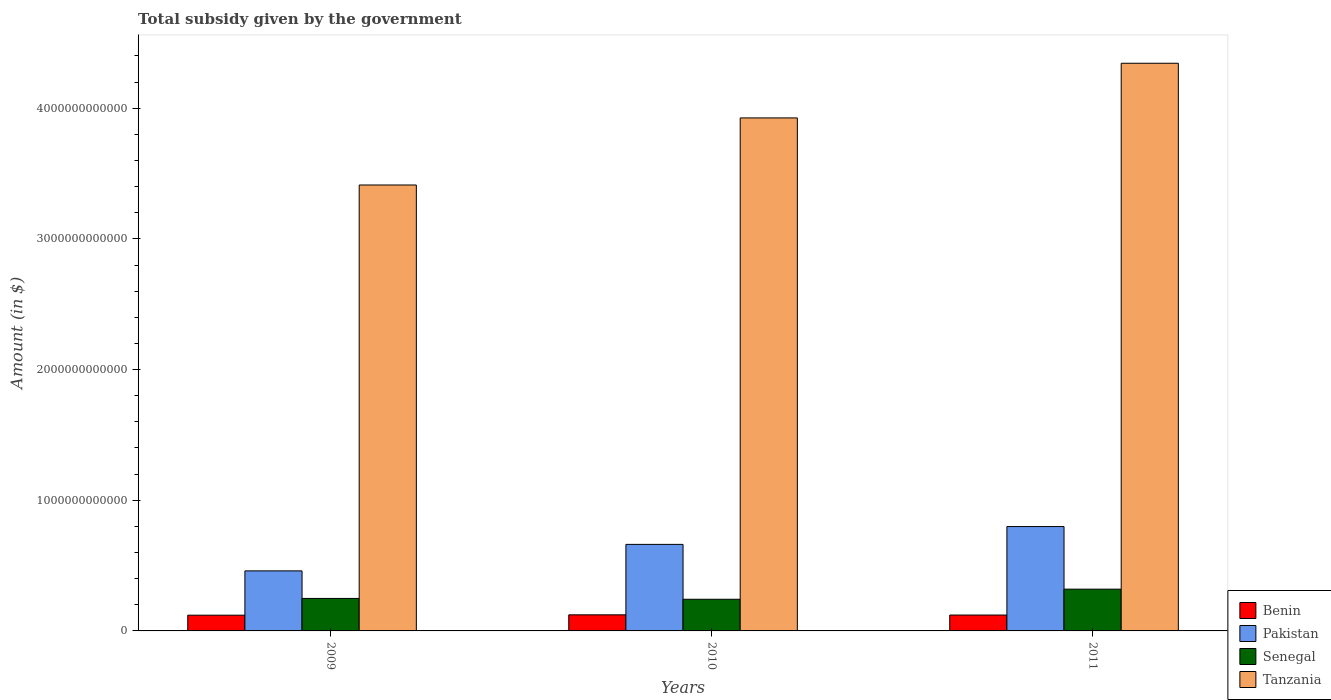How many groups of bars are there?
Your answer should be very brief. 3. Are the number of bars per tick equal to the number of legend labels?
Make the answer very short. Yes. How many bars are there on the 1st tick from the right?
Offer a very short reply. 4. What is the total revenue collected by the government in Pakistan in 2011?
Keep it short and to the point. 7.99e+11. Across all years, what is the maximum total revenue collected by the government in Pakistan?
Give a very brief answer. 7.99e+11. Across all years, what is the minimum total revenue collected by the government in Pakistan?
Your answer should be compact. 4.59e+11. In which year was the total revenue collected by the government in Tanzania maximum?
Provide a succinct answer. 2011. What is the total total revenue collected by the government in Benin in the graph?
Give a very brief answer. 3.65e+11. What is the difference between the total revenue collected by the government in Benin in 2009 and that in 2011?
Your answer should be very brief. -1.11e+09. What is the difference between the total revenue collected by the government in Pakistan in 2010 and the total revenue collected by the government in Benin in 2009?
Ensure brevity in your answer.  5.42e+11. What is the average total revenue collected by the government in Tanzania per year?
Your response must be concise. 3.89e+12. In the year 2010, what is the difference between the total revenue collected by the government in Senegal and total revenue collected by the government in Tanzania?
Make the answer very short. -3.68e+12. In how many years, is the total revenue collected by the government in Pakistan greater than 2000000000000 $?
Offer a terse response. 0. What is the ratio of the total revenue collected by the government in Benin in 2009 to that in 2010?
Your answer should be very brief. 0.98. Is the total revenue collected by the government in Tanzania in 2010 less than that in 2011?
Provide a succinct answer. Yes. Is the difference between the total revenue collected by the government in Senegal in 2010 and 2011 greater than the difference between the total revenue collected by the government in Tanzania in 2010 and 2011?
Give a very brief answer. Yes. What is the difference between the highest and the second highest total revenue collected by the government in Benin?
Give a very brief answer. 1.58e+09. What is the difference between the highest and the lowest total revenue collected by the government in Pakistan?
Your answer should be compact. 3.39e+11. Is the sum of the total revenue collected by the government in Tanzania in 2009 and 2011 greater than the maximum total revenue collected by the government in Pakistan across all years?
Your response must be concise. Yes. What does the 2nd bar from the left in 2009 represents?
Offer a terse response. Pakistan. What does the 1st bar from the right in 2010 represents?
Offer a terse response. Tanzania. How many bars are there?
Ensure brevity in your answer.  12. Are all the bars in the graph horizontal?
Offer a very short reply. No. What is the difference between two consecutive major ticks on the Y-axis?
Give a very brief answer. 1.00e+12. How many legend labels are there?
Your response must be concise. 4. How are the legend labels stacked?
Make the answer very short. Vertical. What is the title of the graph?
Give a very brief answer. Total subsidy given by the government. What is the label or title of the Y-axis?
Provide a short and direct response. Amount (in $). What is the Amount (in $) of Benin in 2009?
Offer a very short reply. 1.20e+11. What is the Amount (in $) in Pakistan in 2009?
Keep it short and to the point. 4.59e+11. What is the Amount (in $) of Senegal in 2009?
Your answer should be compact. 2.49e+11. What is the Amount (in $) in Tanzania in 2009?
Provide a short and direct response. 3.41e+12. What is the Amount (in $) in Benin in 2010?
Keep it short and to the point. 1.23e+11. What is the Amount (in $) in Pakistan in 2010?
Provide a succinct answer. 6.62e+11. What is the Amount (in $) of Senegal in 2010?
Ensure brevity in your answer.  2.42e+11. What is the Amount (in $) of Tanzania in 2010?
Provide a succinct answer. 3.93e+12. What is the Amount (in $) of Benin in 2011?
Your answer should be compact. 1.22e+11. What is the Amount (in $) of Pakistan in 2011?
Offer a very short reply. 7.99e+11. What is the Amount (in $) in Senegal in 2011?
Provide a short and direct response. 3.20e+11. What is the Amount (in $) of Tanzania in 2011?
Give a very brief answer. 4.34e+12. Across all years, what is the maximum Amount (in $) in Benin?
Keep it short and to the point. 1.23e+11. Across all years, what is the maximum Amount (in $) of Pakistan?
Your answer should be very brief. 7.99e+11. Across all years, what is the maximum Amount (in $) in Senegal?
Your answer should be very brief. 3.20e+11. Across all years, what is the maximum Amount (in $) of Tanzania?
Your response must be concise. 4.34e+12. Across all years, what is the minimum Amount (in $) of Benin?
Give a very brief answer. 1.20e+11. Across all years, what is the minimum Amount (in $) of Pakistan?
Keep it short and to the point. 4.59e+11. Across all years, what is the minimum Amount (in $) of Senegal?
Your answer should be very brief. 2.42e+11. Across all years, what is the minimum Amount (in $) in Tanzania?
Ensure brevity in your answer.  3.41e+12. What is the total Amount (in $) in Benin in the graph?
Offer a terse response. 3.65e+11. What is the total Amount (in $) in Pakistan in the graph?
Your answer should be compact. 1.92e+12. What is the total Amount (in $) in Senegal in the graph?
Ensure brevity in your answer.  8.10e+11. What is the total Amount (in $) in Tanzania in the graph?
Offer a terse response. 1.17e+13. What is the difference between the Amount (in $) in Benin in 2009 and that in 2010?
Your response must be concise. -2.69e+09. What is the difference between the Amount (in $) in Pakistan in 2009 and that in 2010?
Provide a succinct answer. -2.03e+11. What is the difference between the Amount (in $) in Senegal in 2009 and that in 2010?
Offer a very short reply. 6.30e+09. What is the difference between the Amount (in $) of Tanzania in 2009 and that in 2010?
Ensure brevity in your answer.  -5.13e+11. What is the difference between the Amount (in $) of Benin in 2009 and that in 2011?
Keep it short and to the point. -1.11e+09. What is the difference between the Amount (in $) in Pakistan in 2009 and that in 2011?
Your response must be concise. -3.39e+11. What is the difference between the Amount (in $) of Senegal in 2009 and that in 2011?
Your response must be concise. -7.10e+1. What is the difference between the Amount (in $) in Tanzania in 2009 and that in 2011?
Keep it short and to the point. -9.32e+11. What is the difference between the Amount (in $) of Benin in 2010 and that in 2011?
Provide a succinct answer. 1.58e+09. What is the difference between the Amount (in $) of Pakistan in 2010 and that in 2011?
Offer a very short reply. -1.36e+11. What is the difference between the Amount (in $) in Senegal in 2010 and that in 2011?
Offer a terse response. -7.73e+1. What is the difference between the Amount (in $) in Tanzania in 2010 and that in 2011?
Make the answer very short. -4.18e+11. What is the difference between the Amount (in $) of Benin in 2009 and the Amount (in $) of Pakistan in 2010?
Make the answer very short. -5.42e+11. What is the difference between the Amount (in $) of Benin in 2009 and the Amount (in $) of Senegal in 2010?
Make the answer very short. -1.22e+11. What is the difference between the Amount (in $) in Benin in 2009 and the Amount (in $) in Tanzania in 2010?
Keep it short and to the point. -3.81e+12. What is the difference between the Amount (in $) of Pakistan in 2009 and the Amount (in $) of Senegal in 2010?
Offer a terse response. 2.17e+11. What is the difference between the Amount (in $) in Pakistan in 2009 and the Amount (in $) in Tanzania in 2010?
Give a very brief answer. -3.47e+12. What is the difference between the Amount (in $) of Senegal in 2009 and the Amount (in $) of Tanzania in 2010?
Ensure brevity in your answer.  -3.68e+12. What is the difference between the Amount (in $) of Benin in 2009 and the Amount (in $) of Pakistan in 2011?
Offer a terse response. -6.78e+11. What is the difference between the Amount (in $) of Benin in 2009 and the Amount (in $) of Senegal in 2011?
Provide a short and direct response. -1.99e+11. What is the difference between the Amount (in $) of Benin in 2009 and the Amount (in $) of Tanzania in 2011?
Provide a short and direct response. -4.22e+12. What is the difference between the Amount (in $) of Pakistan in 2009 and the Amount (in $) of Senegal in 2011?
Provide a short and direct response. 1.40e+11. What is the difference between the Amount (in $) in Pakistan in 2009 and the Amount (in $) in Tanzania in 2011?
Your answer should be compact. -3.88e+12. What is the difference between the Amount (in $) in Senegal in 2009 and the Amount (in $) in Tanzania in 2011?
Offer a terse response. -4.10e+12. What is the difference between the Amount (in $) in Benin in 2010 and the Amount (in $) in Pakistan in 2011?
Offer a terse response. -6.76e+11. What is the difference between the Amount (in $) in Benin in 2010 and the Amount (in $) in Senegal in 2011?
Provide a succinct answer. -1.97e+11. What is the difference between the Amount (in $) in Benin in 2010 and the Amount (in $) in Tanzania in 2011?
Provide a succinct answer. -4.22e+12. What is the difference between the Amount (in $) in Pakistan in 2010 and the Amount (in $) in Senegal in 2011?
Offer a terse response. 3.43e+11. What is the difference between the Amount (in $) of Pakistan in 2010 and the Amount (in $) of Tanzania in 2011?
Offer a very short reply. -3.68e+12. What is the difference between the Amount (in $) in Senegal in 2010 and the Amount (in $) in Tanzania in 2011?
Your response must be concise. -4.10e+12. What is the average Amount (in $) in Benin per year?
Offer a terse response. 1.22e+11. What is the average Amount (in $) of Pakistan per year?
Give a very brief answer. 6.40e+11. What is the average Amount (in $) of Senegal per year?
Provide a short and direct response. 2.70e+11. What is the average Amount (in $) in Tanzania per year?
Make the answer very short. 3.89e+12. In the year 2009, what is the difference between the Amount (in $) of Benin and Amount (in $) of Pakistan?
Offer a very short reply. -3.39e+11. In the year 2009, what is the difference between the Amount (in $) in Benin and Amount (in $) in Senegal?
Give a very brief answer. -1.28e+11. In the year 2009, what is the difference between the Amount (in $) in Benin and Amount (in $) in Tanzania?
Make the answer very short. -3.29e+12. In the year 2009, what is the difference between the Amount (in $) in Pakistan and Amount (in $) in Senegal?
Your answer should be compact. 2.11e+11. In the year 2009, what is the difference between the Amount (in $) of Pakistan and Amount (in $) of Tanzania?
Provide a short and direct response. -2.95e+12. In the year 2009, what is the difference between the Amount (in $) of Senegal and Amount (in $) of Tanzania?
Keep it short and to the point. -3.16e+12. In the year 2010, what is the difference between the Amount (in $) of Benin and Amount (in $) of Pakistan?
Your response must be concise. -5.39e+11. In the year 2010, what is the difference between the Amount (in $) of Benin and Amount (in $) of Senegal?
Your answer should be very brief. -1.19e+11. In the year 2010, what is the difference between the Amount (in $) of Benin and Amount (in $) of Tanzania?
Your answer should be compact. -3.80e+12. In the year 2010, what is the difference between the Amount (in $) of Pakistan and Amount (in $) of Senegal?
Your answer should be compact. 4.20e+11. In the year 2010, what is the difference between the Amount (in $) in Pakistan and Amount (in $) in Tanzania?
Provide a succinct answer. -3.26e+12. In the year 2010, what is the difference between the Amount (in $) in Senegal and Amount (in $) in Tanzania?
Provide a succinct answer. -3.68e+12. In the year 2011, what is the difference between the Amount (in $) in Benin and Amount (in $) in Pakistan?
Provide a succinct answer. -6.77e+11. In the year 2011, what is the difference between the Amount (in $) in Benin and Amount (in $) in Senegal?
Offer a very short reply. -1.98e+11. In the year 2011, what is the difference between the Amount (in $) of Benin and Amount (in $) of Tanzania?
Ensure brevity in your answer.  -4.22e+12. In the year 2011, what is the difference between the Amount (in $) of Pakistan and Amount (in $) of Senegal?
Make the answer very short. 4.79e+11. In the year 2011, what is the difference between the Amount (in $) of Pakistan and Amount (in $) of Tanzania?
Offer a very short reply. -3.55e+12. In the year 2011, what is the difference between the Amount (in $) of Senegal and Amount (in $) of Tanzania?
Provide a short and direct response. -4.02e+12. What is the ratio of the Amount (in $) of Benin in 2009 to that in 2010?
Your response must be concise. 0.98. What is the ratio of the Amount (in $) in Pakistan in 2009 to that in 2010?
Your response must be concise. 0.69. What is the ratio of the Amount (in $) in Senegal in 2009 to that in 2010?
Make the answer very short. 1.03. What is the ratio of the Amount (in $) in Tanzania in 2009 to that in 2010?
Your answer should be very brief. 0.87. What is the ratio of the Amount (in $) of Benin in 2009 to that in 2011?
Give a very brief answer. 0.99. What is the ratio of the Amount (in $) of Pakistan in 2009 to that in 2011?
Offer a terse response. 0.58. What is the ratio of the Amount (in $) in Senegal in 2009 to that in 2011?
Keep it short and to the point. 0.78. What is the ratio of the Amount (in $) in Tanzania in 2009 to that in 2011?
Your answer should be compact. 0.79. What is the ratio of the Amount (in $) of Pakistan in 2010 to that in 2011?
Ensure brevity in your answer.  0.83. What is the ratio of the Amount (in $) in Senegal in 2010 to that in 2011?
Make the answer very short. 0.76. What is the ratio of the Amount (in $) in Tanzania in 2010 to that in 2011?
Your answer should be very brief. 0.9. What is the difference between the highest and the second highest Amount (in $) of Benin?
Keep it short and to the point. 1.58e+09. What is the difference between the highest and the second highest Amount (in $) of Pakistan?
Make the answer very short. 1.36e+11. What is the difference between the highest and the second highest Amount (in $) of Senegal?
Your answer should be compact. 7.10e+1. What is the difference between the highest and the second highest Amount (in $) in Tanzania?
Provide a short and direct response. 4.18e+11. What is the difference between the highest and the lowest Amount (in $) of Benin?
Provide a succinct answer. 2.69e+09. What is the difference between the highest and the lowest Amount (in $) of Pakistan?
Your response must be concise. 3.39e+11. What is the difference between the highest and the lowest Amount (in $) of Senegal?
Your answer should be very brief. 7.73e+1. What is the difference between the highest and the lowest Amount (in $) of Tanzania?
Give a very brief answer. 9.32e+11. 